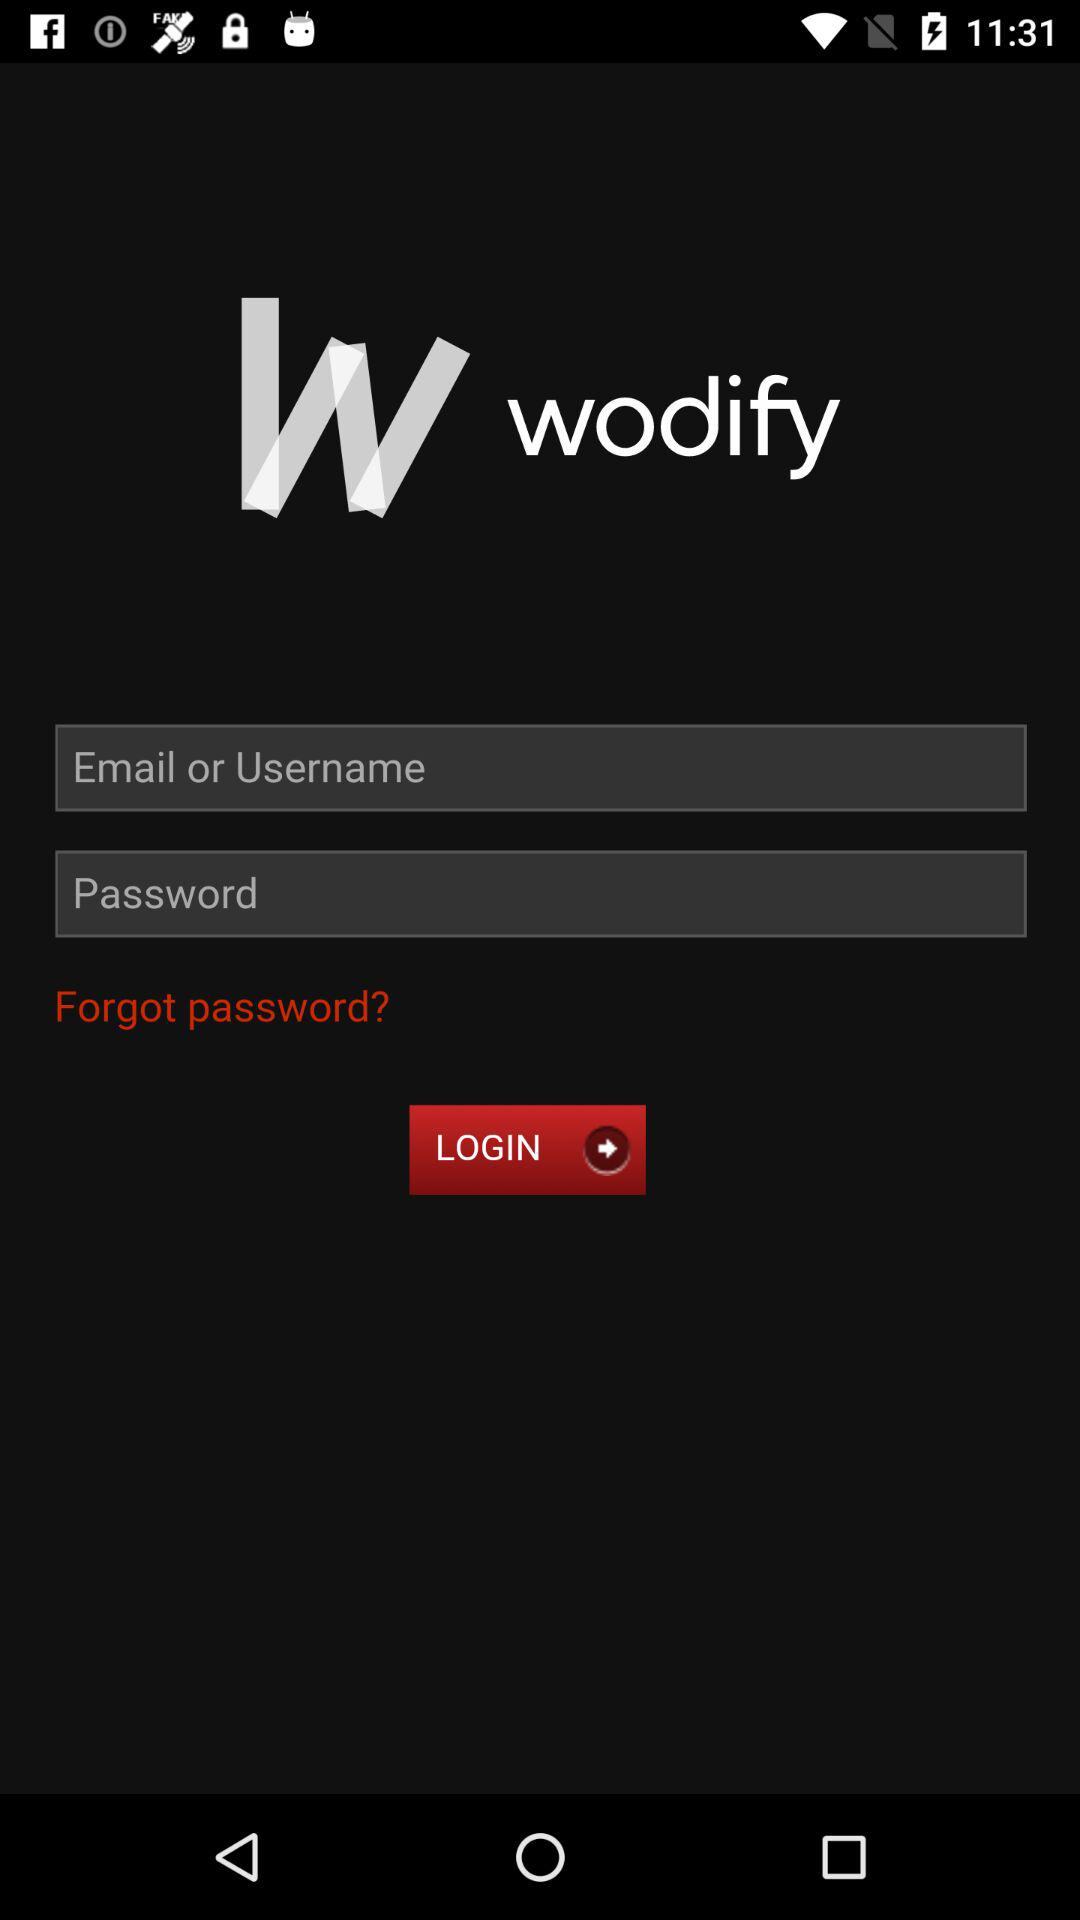What is the application name? The application name is "wodify". 